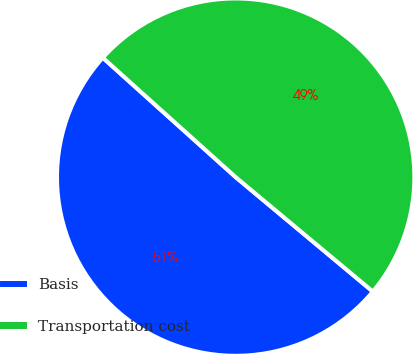Convert chart. <chart><loc_0><loc_0><loc_500><loc_500><pie_chart><fcel>Basis<fcel>Transportation cost<nl><fcel>50.59%<fcel>49.41%<nl></chart> 